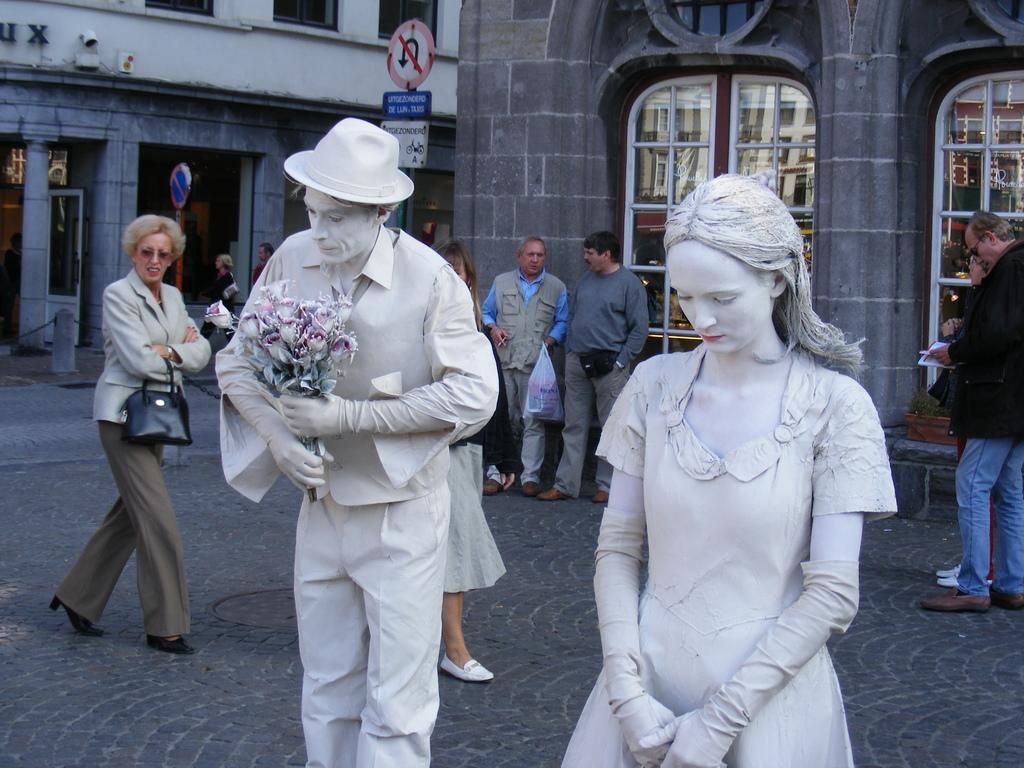Describe this image in one or two sentences. In the middle of the image few people are standing and walking. Behind them we can see some buildings, poles and sign boards. 